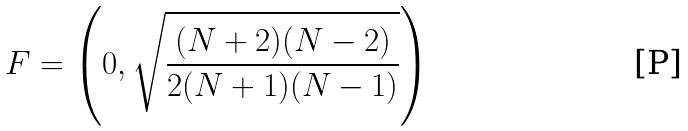Convert formula to latex. <formula><loc_0><loc_0><loc_500><loc_500>F = \left ( 0 , \sqrt { \frac { ( N + 2 ) ( N - 2 ) } { 2 ( N + 1 ) ( N - 1 ) } } \right )</formula> 